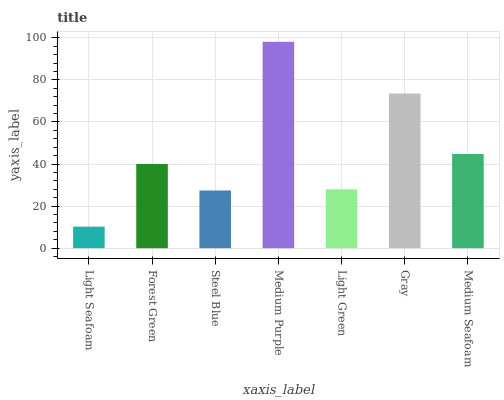Is Light Seafoam the minimum?
Answer yes or no. Yes. Is Medium Purple the maximum?
Answer yes or no. Yes. Is Forest Green the minimum?
Answer yes or no. No. Is Forest Green the maximum?
Answer yes or no. No. Is Forest Green greater than Light Seafoam?
Answer yes or no. Yes. Is Light Seafoam less than Forest Green?
Answer yes or no. Yes. Is Light Seafoam greater than Forest Green?
Answer yes or no. No. Is Forest Green less than Light Seafoam?
Answer yes or no. No. Is Forest Green the high median?
Answer yes or no. Yes. Is Forest Green the low median?
Answer yes or no. Yes. Is Medium Purple the high median?
Answer yes or no. No. Is Medium Seafoam the low median?
Answer yes or no. No. 